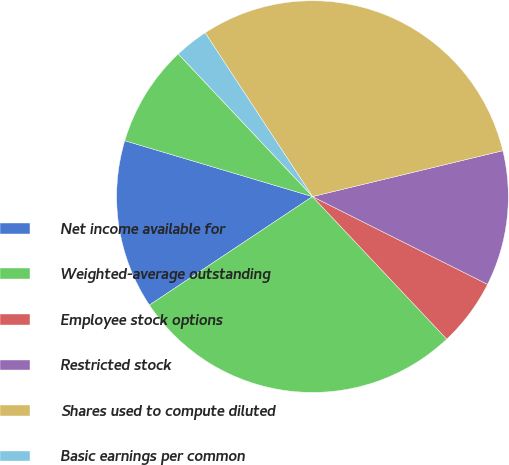Convert chart. <chart><loc_0><loc_0><loc_500><loc_500><pie_chart><fcel>Net income available for<fcel>Weighted-average outstanding<fcel>Employee stock options<fcel>Restricted stock<fcel>Shares used to compute diluted<fcel>Basic earnings per common<fcel>Diluted earnings per common<fcel>Number of antidilutive stock<nl><fcel>13.95%<fcel>27.68%<fcel>5.58%<fcel>11.16%<fcel>30.47%<fcel>2.79%<fcel>0.0%<fcel>8.37%<nl></chart> 